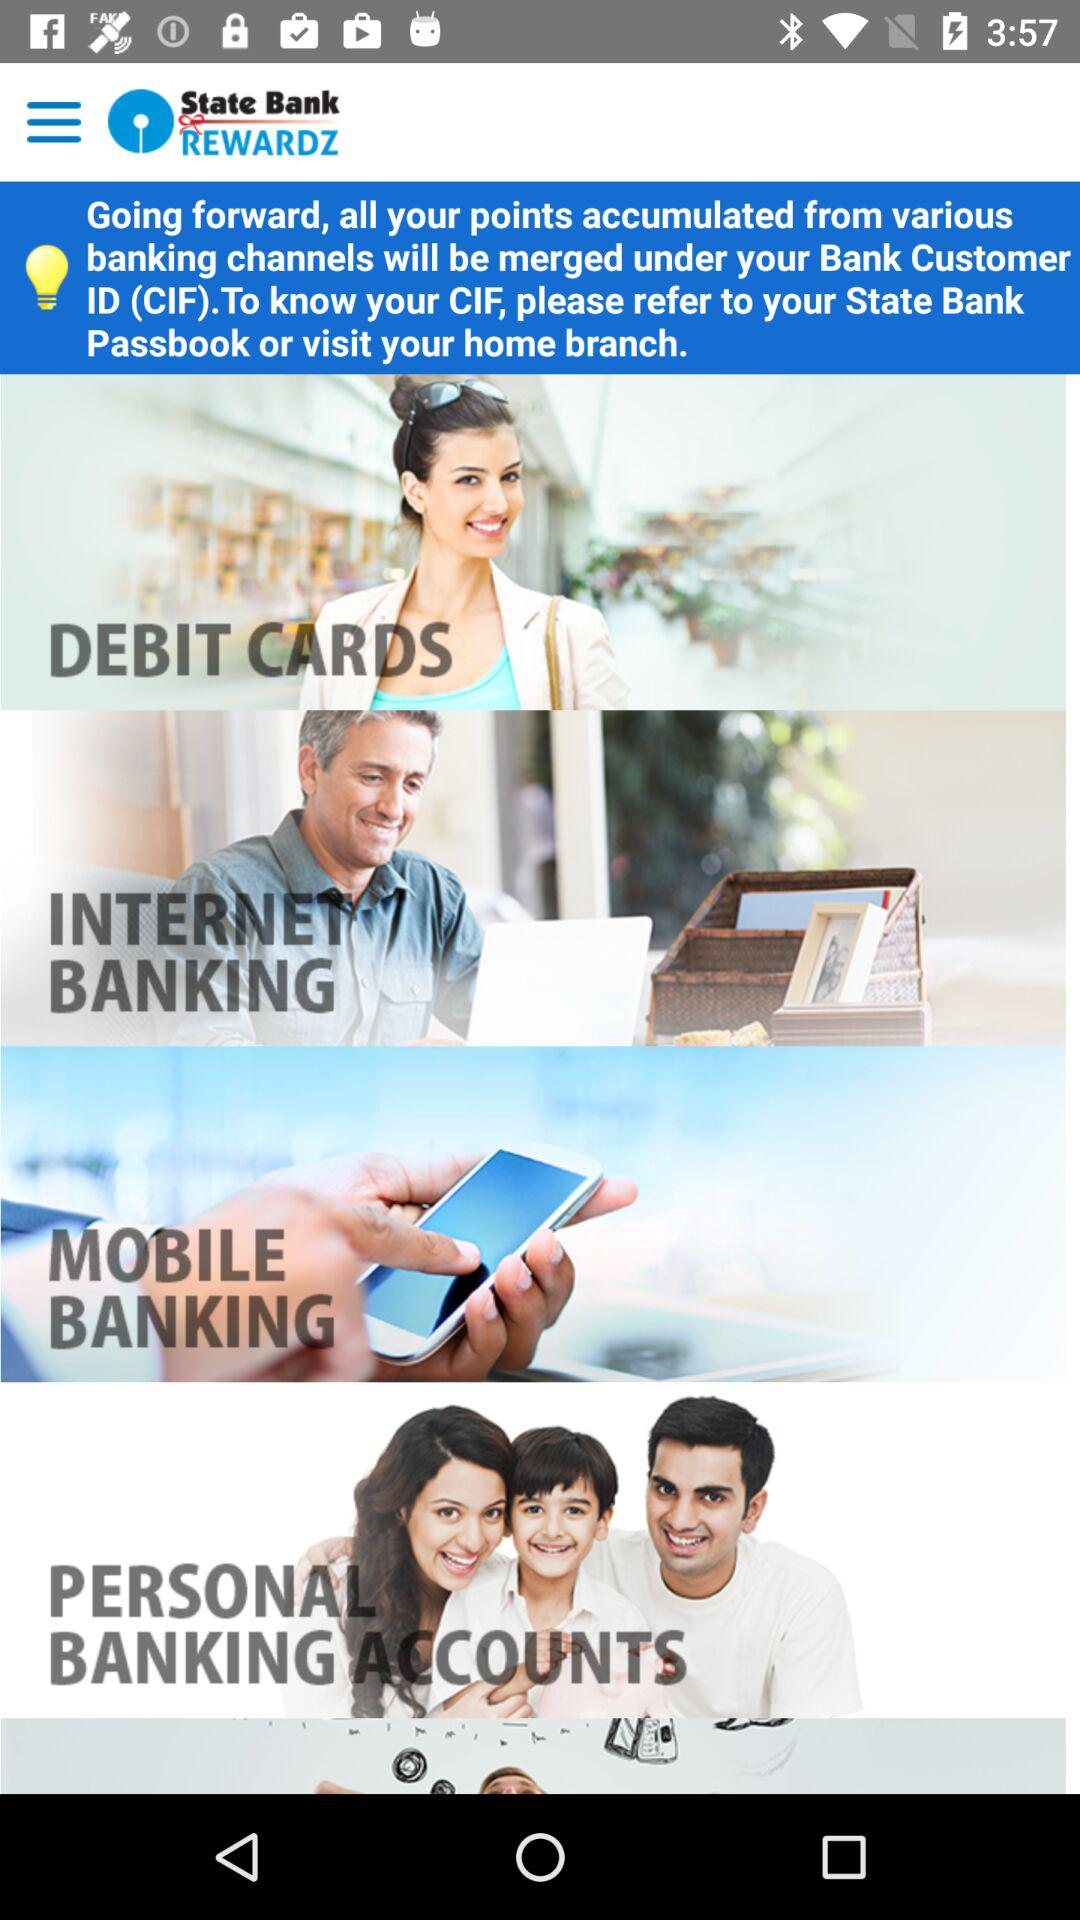Who is this application powered by?
When the provided information is insufficient, respond with <no answer>. <no answer> 